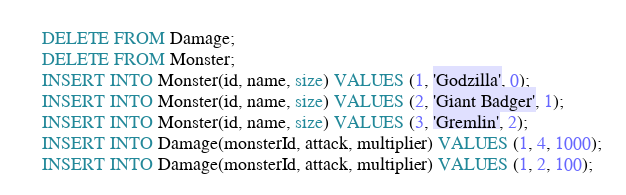Convert code to text. <code><loc_0><loc_0><loc_500><loc_500><_SQL_>DELETE FROM Damage;
DELETE FROM Monster;
INSERT INTO Monster(id, name, size) VALUES (1, 'Godzilla', 0);
INSERT INTO Monster(id, name, size) VALUES (2, 'Giant Badger', 1);
INSERT INTO Monster(id, name, size) VALUES (3, 'Gremlin', 2);
INSERT INTO Damage(monsterId, attack, multiplier) VALUES (1, 4, 1000);
INSERT INTO Damage(monsterId, attack, multiplier) VALUES (1, 2, 100);</code> 